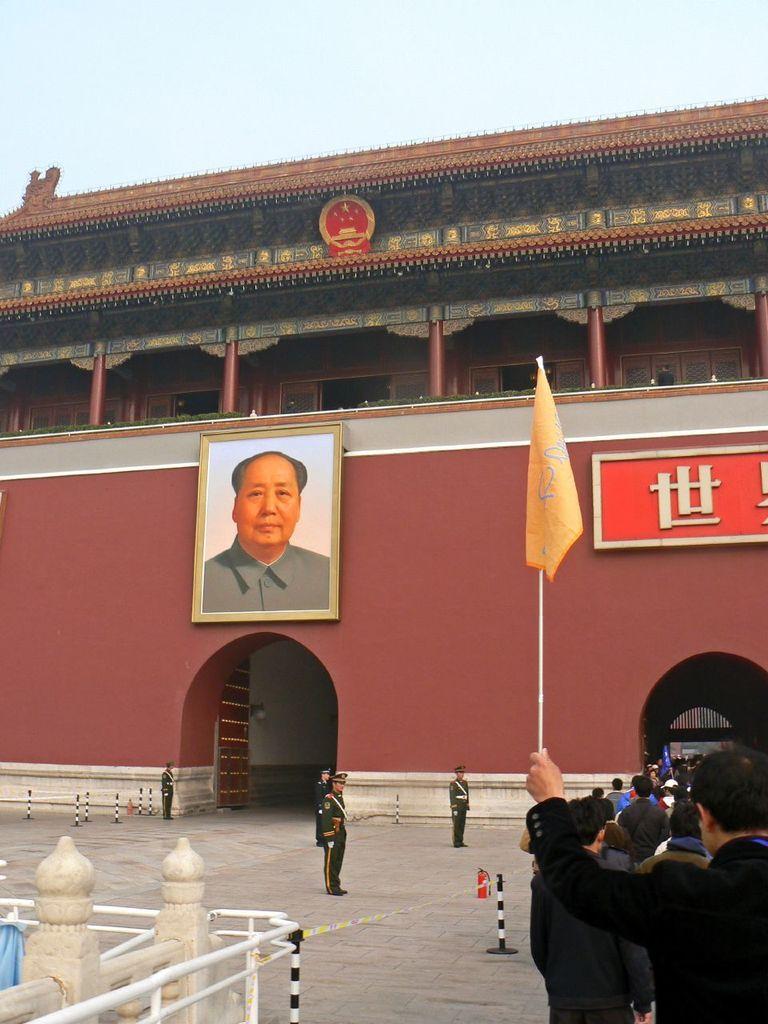Could you give a brief overview of what you see in this image? In this picture we can see there are groups of people on the walkway. A person is holding a stick with a flag. On the right side of the image there are iron grilles. In front of the people there is a photo frame and a name board on the wall. Behind the building there is the sky. 